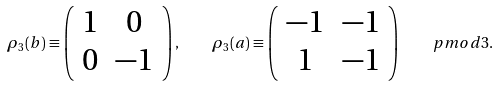Convert formula to latex. <formula><loc_0><loc_0><loc_500><loc_500>\rho _ { 3 } ( b ) \equiv \left ( \begin{array} { c c } 1 & 0 \\ 0 & - 1 \end{array} \right ) , \quad \rho _ { 3 } ( a ) \equiv \left ( \begin{array} { c c } - 1 & - 1 \\ 1 & - 1 \end{array} \right ) \quad p m o d { 3 } .</formula> 